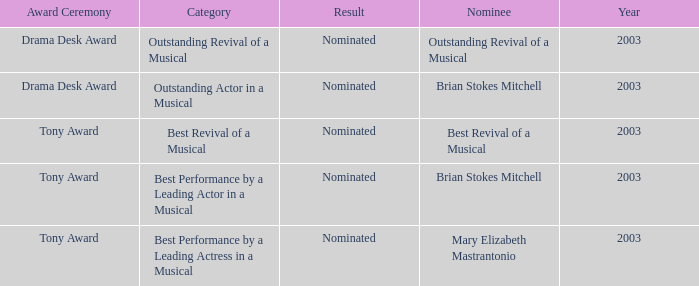What was the result for the nomination of Best Revival of a Musical? Nominated. 